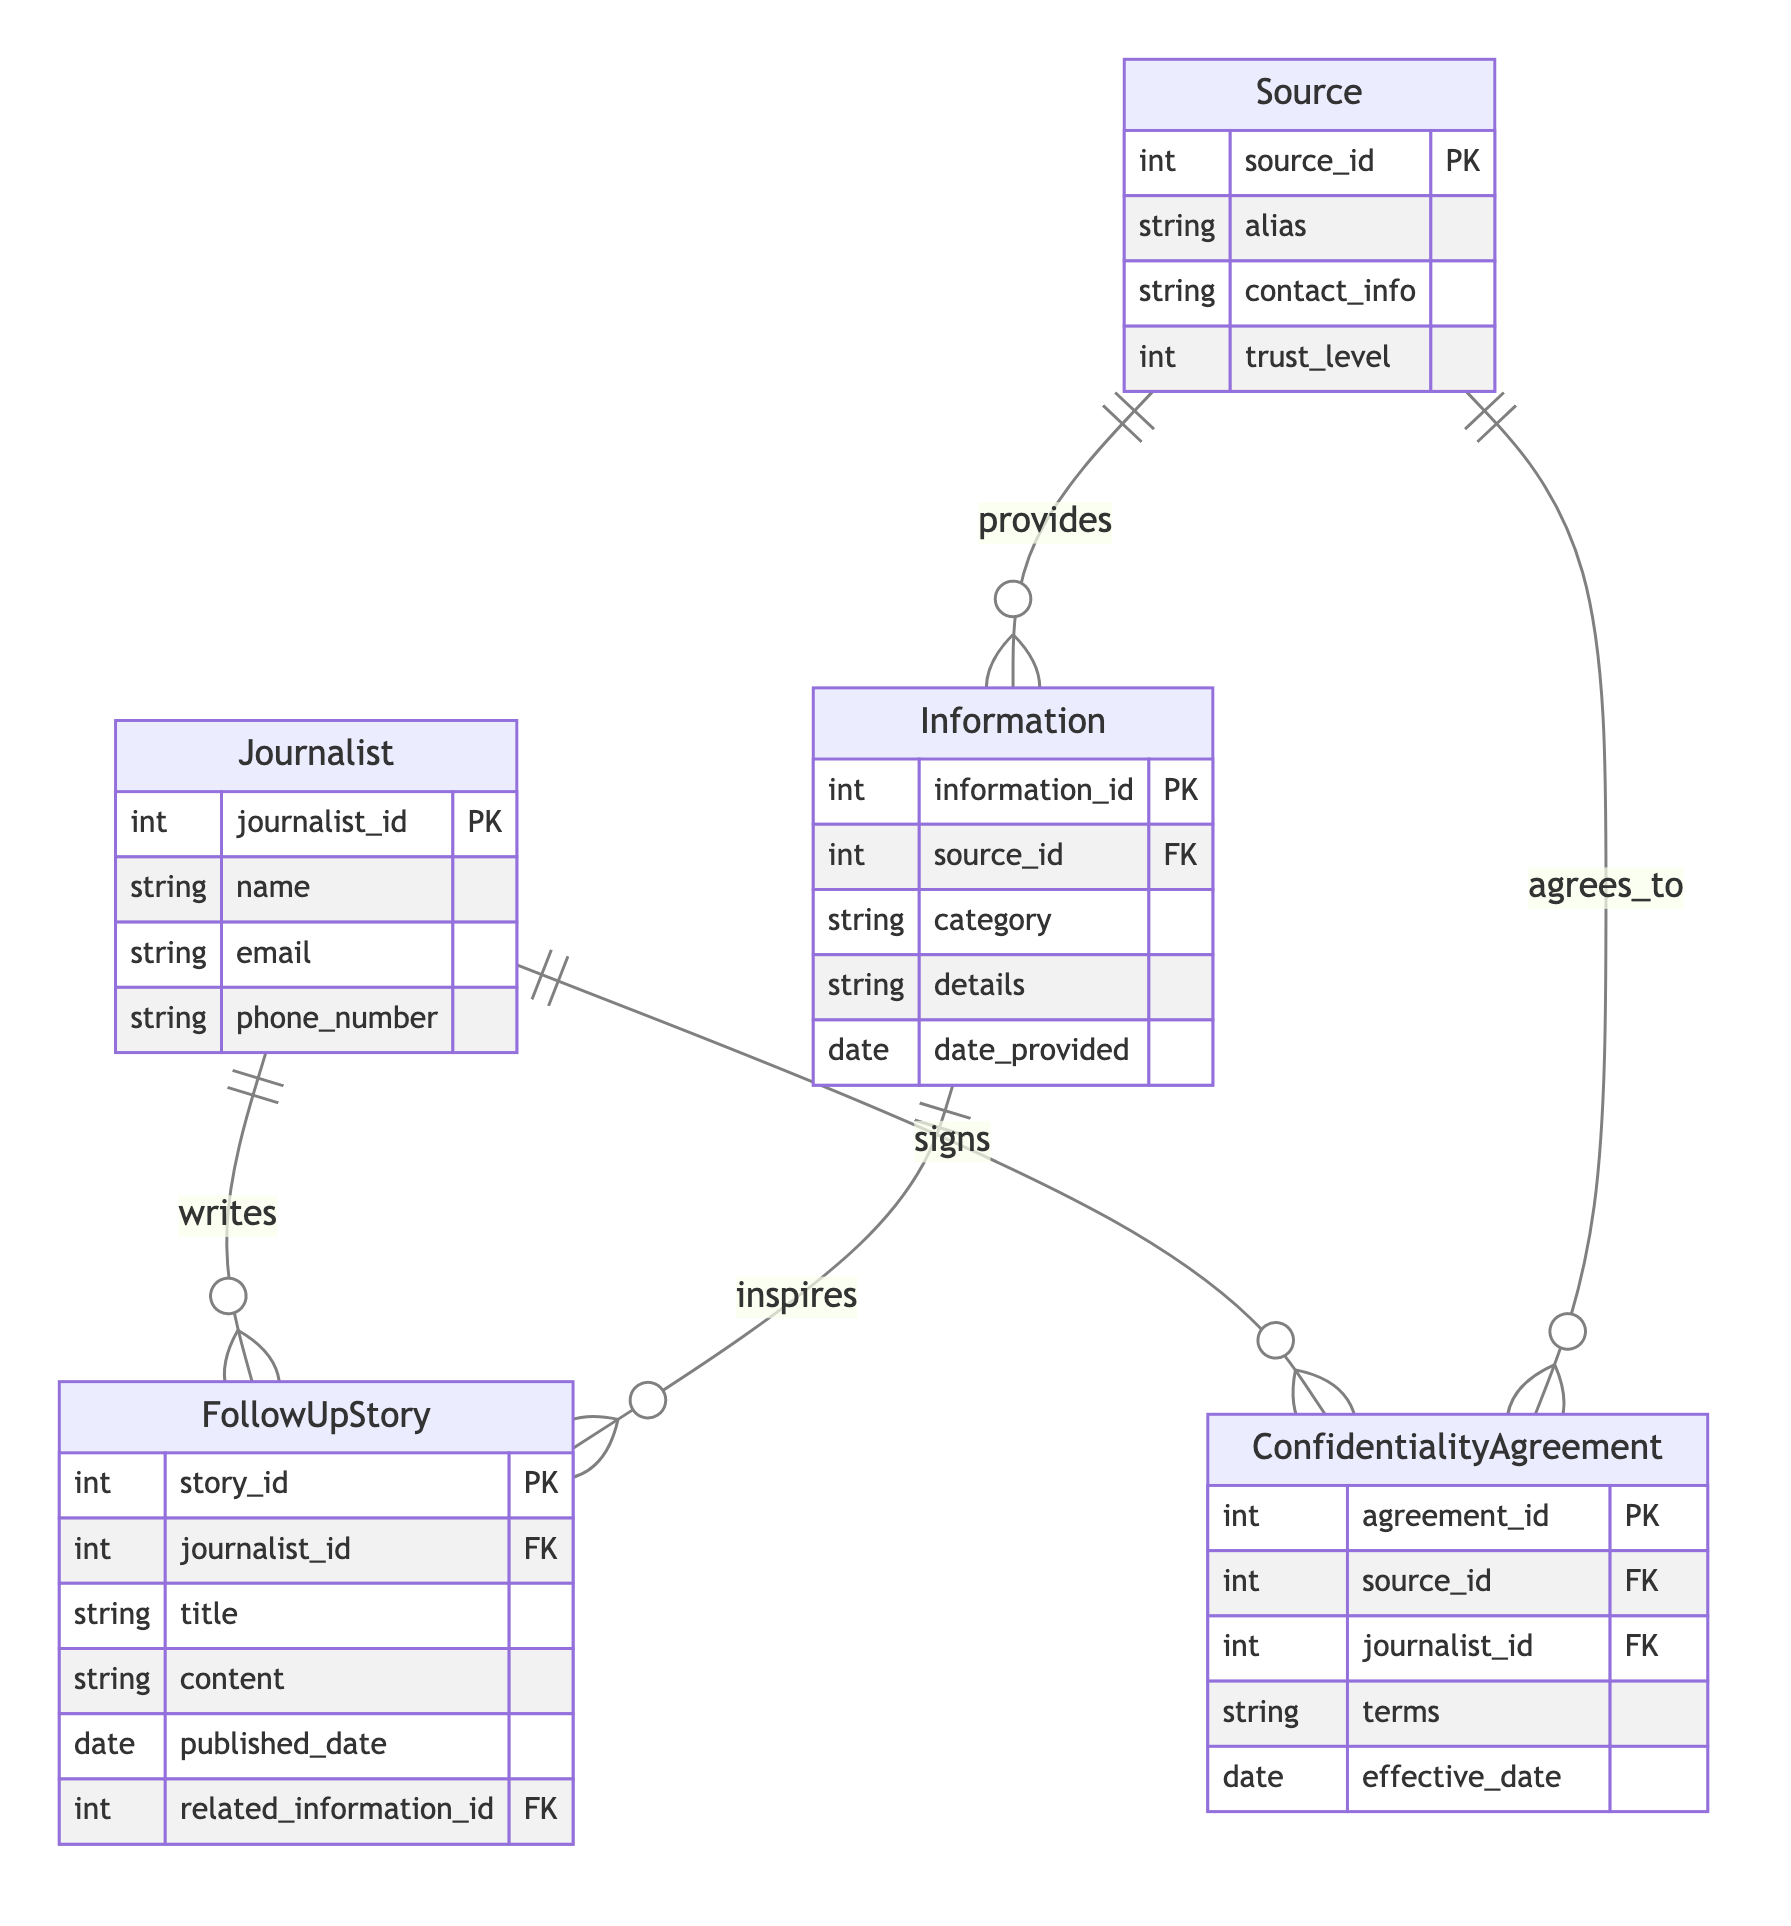What entities are present in the diagram? The diagram includes the entities: Journalist, Source, Information, Confidentiality Agreement, and FollowUp Story. Each of these represents a core component of the Confidential Source Management system.
Answer: Journalist, Source, Information, Confidentiality Agreement, FollowUp Story How many relationships are there between the Journalist and FollowUp Story? There is a one-to-many relationship from Journalist to FollowUp Story, indicating that a single journalist can write multiple follow-up stories. This is a single relationship type but indicates multiple instances.
Answer: One What is the trust level attribute associated with? The trust level attribute is associated with the Source entity, indicating the degree of reliability of the source provided to the journalist.
Answer: Source How many total entities are described in the diagram? The diagram describes five total entities, detailing the various components involved in managing confidential sources and their interactions.
Answer: Five Which entity is responsible for signing confidentiality agreements? The Journalist entity is responsible for signing confidentiality agreements, establishing a formal understanding with the sources regarding the confidentiality of information.
Answer: Journalist What type of relationship exists between Source and Information? There is a one-to-many relationship from Source to Information, meaning that a single source can provide multiple pieces of information.
Answer: One to many How many follow-up stories can a single journalist write? A single journalist can write many follow-up stories because the relationship is one-to-many from Journalist to FollowUp Story.
Answer: Many What does the Confidentiality Agreement entity establish between Source and Journalist? The Confidentiality Agreement entity establishes the terms and conditions between the Source and Journalist regarding how the information shared will be handled.
Answer: Terms Which entity provides the information? The Source entity is the one that provides the information, indicating the role of individuals or organizations in supplying newsworthy content to journalists.
Answer: Source 